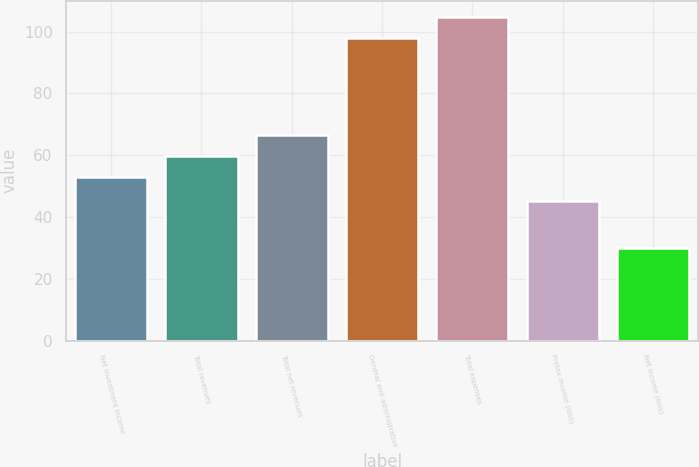Convert chart. <chart><loc_0><loc_0><loc_500><loc_500><bar_chart><fcel>Net investment income<fcel>Total revenues<fcel>Total net revenues<fcel>General and administrative<fcel>Total expenses<fcel>Pretax income (loss)<fcel>Net income (loss)<nl><fcel>53<fcel>59.8<fcel>66.6<fcel>98<fcel>104.8<fcel>45<fcel>30<nl></chart> 